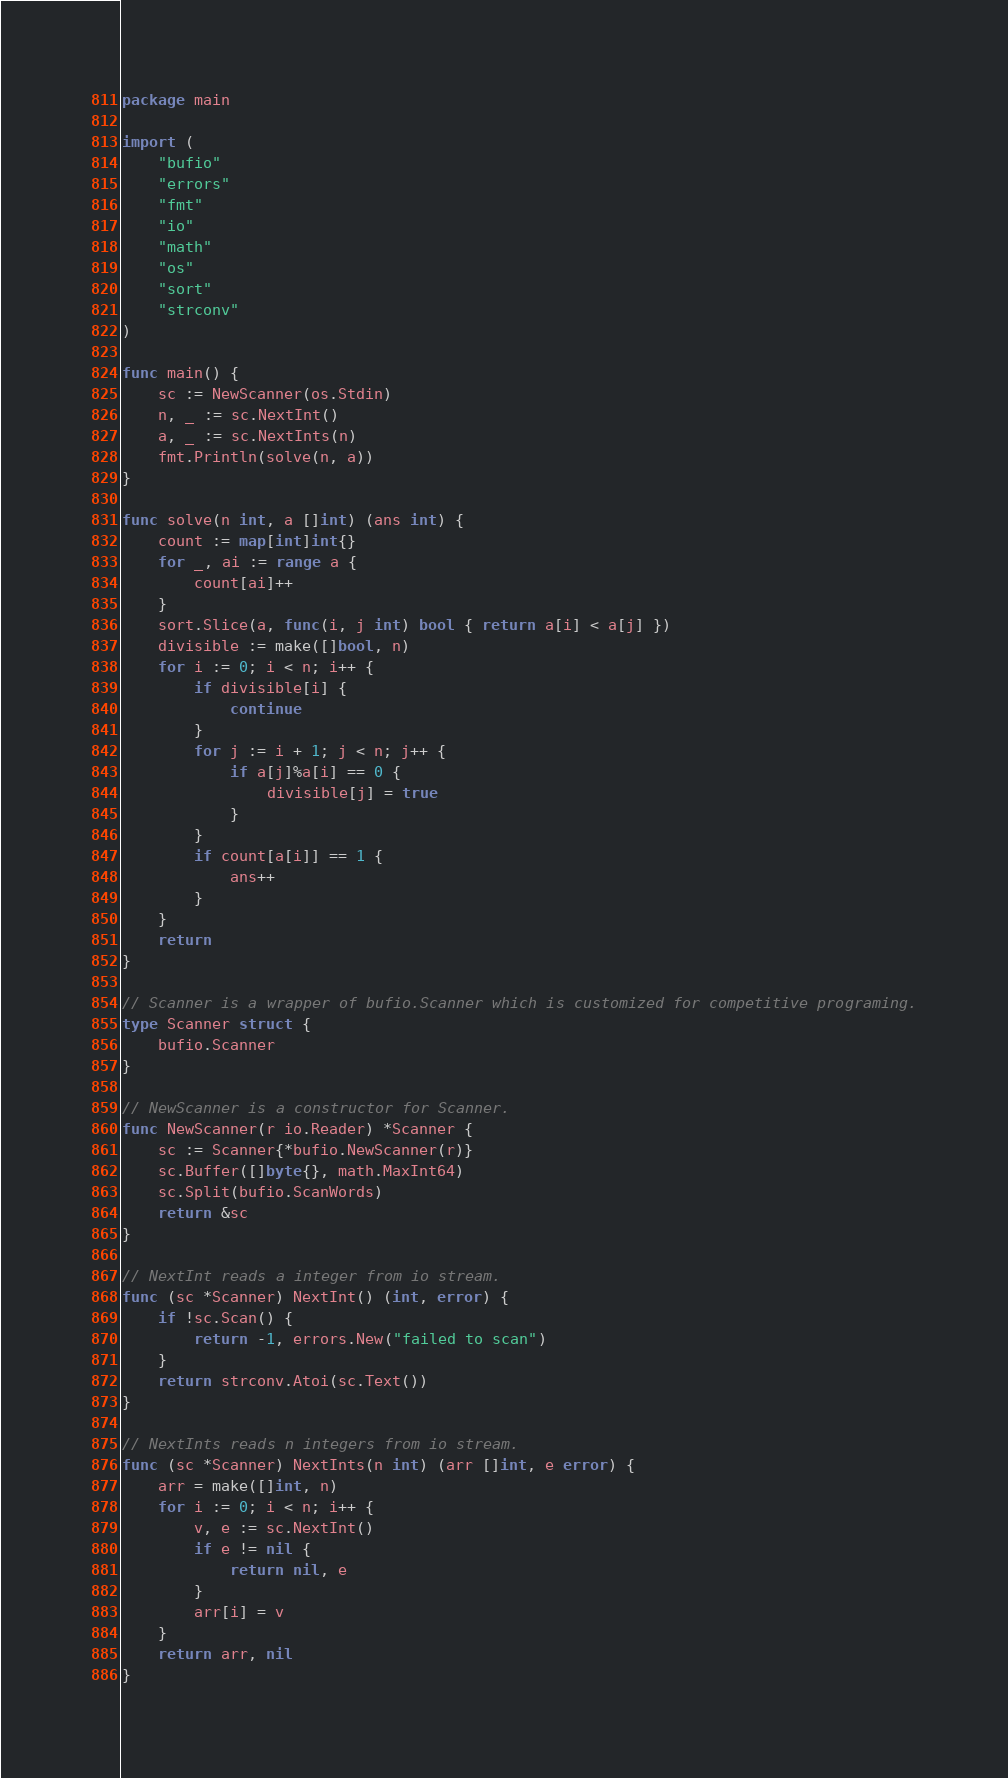Convert code to text. <code><loc_0><loc_0><loc_500><loc_500><_Go_>package main

import (
	"bufio"
	"errors"
	"fmt"
	"io"
	"math"
	"os"
	"sort"
	"strconv"
)

func main() {
	sc := NewScanner(os.Stdin)
	n, _ := sc.NextInt()
	a, _ := sc.NextInts(n)
	fmt.Println(solve(n, a))
}

func solve(n int, a []int) (ans int) {
	count := map[int]int{}
	for _, ai := range a {
		count[ai]++
	}
	sort.Slice(a, func(i, j int) bool { return a[i] < a[j] })
	divisible := make([]bool, n)
	for i := 0; i < n; i++ {
		if divisible[i] {
			continue
		}
		for j := i + 1; j < n; j++ {
			if a[j]%a[i] == 0 {
				divisible[j] = true
			}
		}
		if count[a[i]] == 1 {
			ans++
		}
	}
	return
}

// Scanner is a wrapper of bufio.Scanner which is customized for competitive programing.
type Scanner struct {
	bufio.Scanner
}

// NewScanner is a constructor for Scanner.
func NewScanner(r io.Reader) *Scanner {
	sc := Scanner{*bufio.NewScanner(r)}
	sc.Buffer([]byte{}, math.MaxInt64)
	sc.Split(bufio.ScanWords)
	return &sc
}

// NextInt reads a integer from io stream.
func (sc *Scanner) NextInt() (int, error) {
	if !sc.Scan() {
		return -1, errors.New("failed to scan")
	}
	return strconv.Atoi(sc.Text())
}

// NextInts reads n integers from io stream.
func (sc *Scanner) NextInts(n int) (arr []int, e error) {
	arr = make([]int, n)
	for i := 0; i < n; i++ {
		v, e := sc.NextInt()
		if e != nil {
			return nil, e
		}
		arr[i] = v
	}
	return arr, nil
}
</code> 